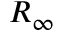<formula> <loc_0><loc_0><loc_500><loc_500>R _ { \infty }</formula> 